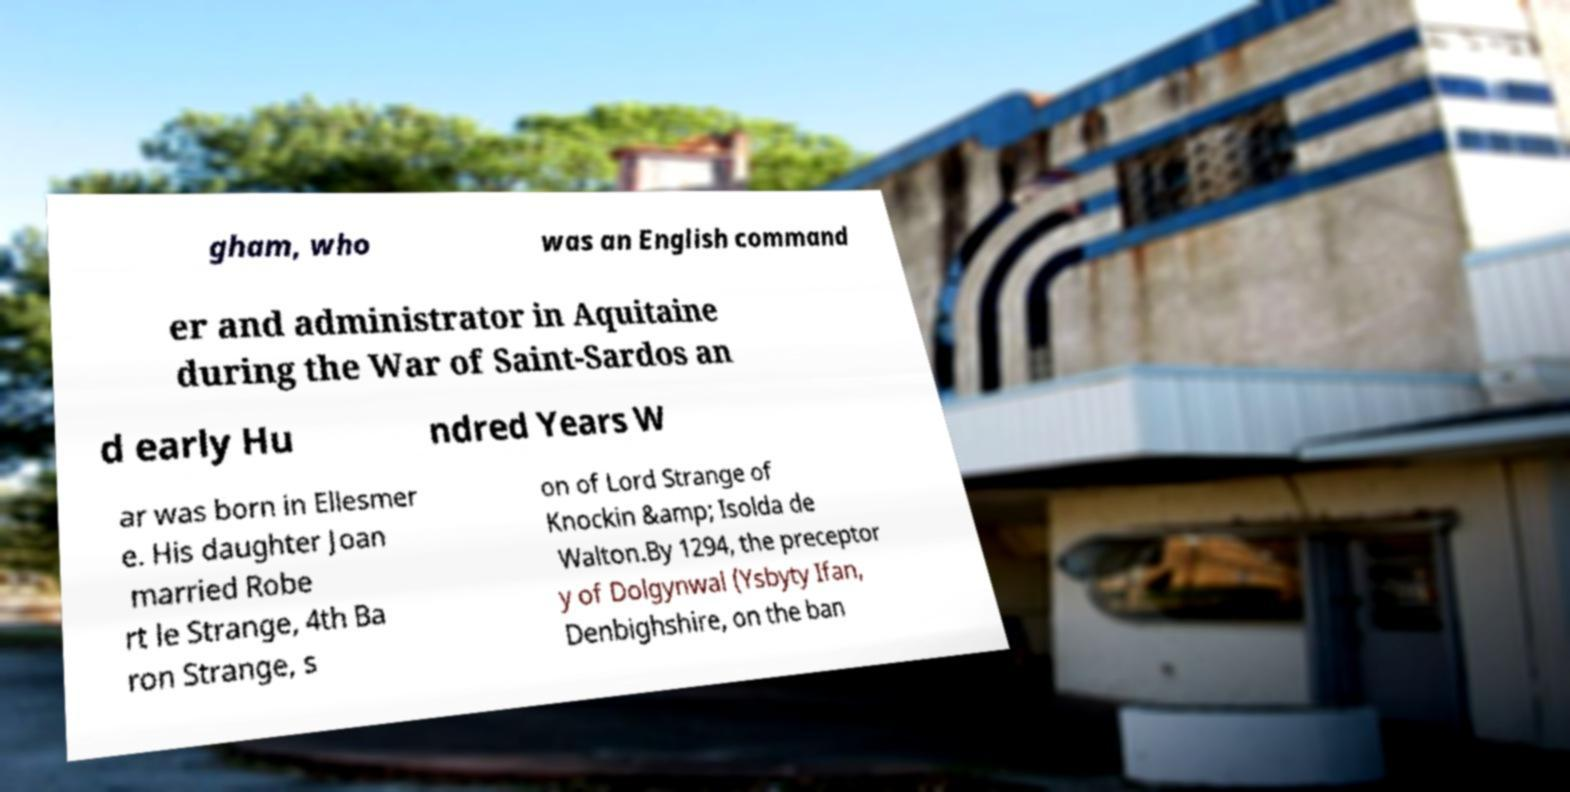There's text embedded in this image that I need extracted. Can you transcribe it verbatim? gham, who was an English command er and administrator in Aquitaine during the War of Saint-Sardos an d early Hu ndred Years W ar was born in Ellesmer e. His daughter Joan married Robe rt le Strange, 4th Ba ron Strange, s on of Lord Strange of Knockin &amp; Isolda de Walton.By 1294, the preceptor y of Dolgynwal (Ysbyty Ifan, Denbighshire, on the ban 